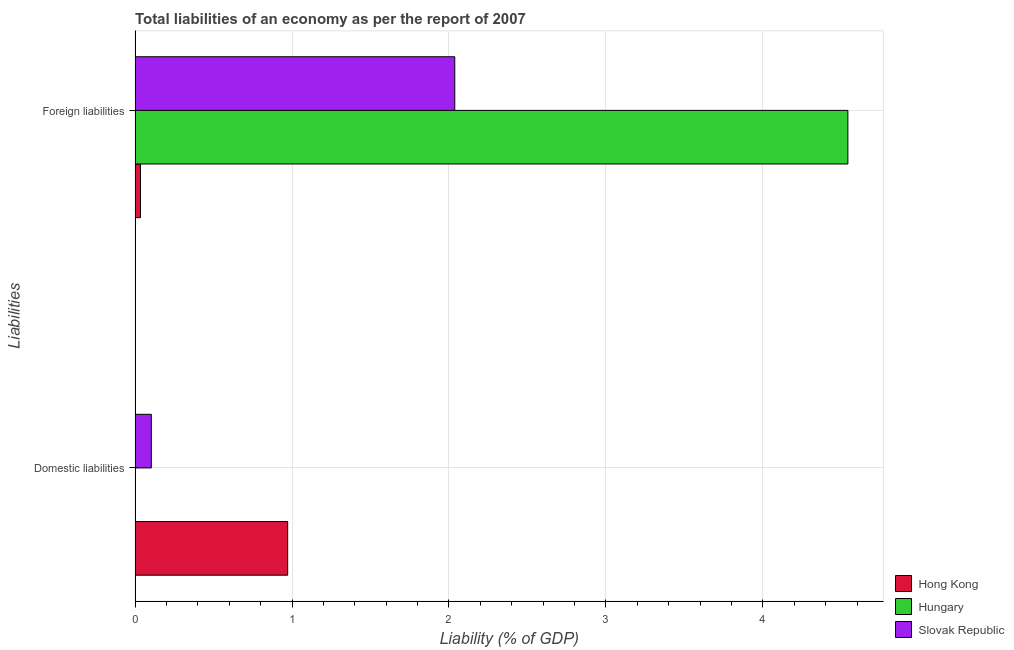Are the number of bars per tick equal to the number of legend labels?
Offer a very short reply. No. Are the number of bars on each tick of the Y-axis equal?
Make the answer very short. No. What is the label of the 1st group of bars from the top?
Offer a terse response. Foreign liabilities. What is the incurrence of foreign liabilities in Hong Kong?
Your response must be concise. 0.03. Across all countries, what is the maximum incurrence of domestic liabilities?
Make the answer very short. 0.97. Across all countries, what is the minimum incurrence of foreign liabilities?
Give a very brief answer. 0.03. In which country was the incurrence of foreign liabilities maximum?
Offer a terse response. Hungary. What is the total incurrence of domestic liabilities in the graph?
Keep it short and to the point. 1.08. What is the difference between the incurrence of foreign liabilities in Hungary and that in Slovak Republic?
Give a very brief answer. 2.5. What is the difference between the incurrence of foreign liabilities in Hong Kong and the incurrence of domestic liabilities in Slovak Republic?
Offer a terse response. -0.07. What is the average incurrence of foreign liabilities per country?
Provide a short and direct response. 2.2. What is the difference between the incurrence of domestic liabilities and incurrence of foreign liabilities in Slovak Republic?
Ensure brevity in your answer.  -1.93. In how many countries, is the incurrence of domestic liabilities greater than 0.2 %?
Ensure brevity in your answer.  1. What is the ratio of the incurrence of foreign liabilities in Slovak Republic to that in Hungary?
Your answer should be very brief. 0.45. In how many countries, is the incurrence of foreign liabilities greater than the average incurrence of foreign liabilities taken over all countries?
Ensure brevity in your answer.  1. How many bars are there?
Ensure brevity in your answer.  5. Are all the bars in the graph horizontal?
Make the answer very short. Yes. What is the difference between two consecutive major ticks on the X-axis?
Make the answer very short. 1. Are the values on the major ticks of X-axis written in scientific E-notation?
Offer a very short reply. No. Does the graph contain any zero values?
Your answer should be very brief. Yes. Does the graph contain grids?
Your answer should be very brief. Yes. Where does the legend appear in the graph?
Ensure brevity in your answer.  Bottom right. How are the legend labels stacked?
Your response must be concise. Vertical. What is the title of the graph?
Offer a very short reply. Total liabilities of an economy as per the report of 2007. Does "North America" appear as one of the legend labels in the graph?
Provide a succinct answer. No. What is the label or title of the X-axis?
Your answer should be compact. Liability (% of GDP). What is the label or title of the Y-axis?
Provide a succinct answer. Liabilities. What is the Liability (% of GDP) in Hong Kong in Domestic liabilities?
Your answer should be compact. 0.97. What is the Liability (% of GDP) in Hungary in Domestic liabilities?
Your answer should be very brief. 0. What is the Liability (% of GDP) in Slovak Republic in Domestic liabilities?
Ensure brevity in your answer.  0.1. What is the Liability (% of GDP) in Hong Kong in Foreign liabilities?
Make the answer very short. 0.03. What is the Liability (% of GDP) of Hungary in Foreign liabilities?
Give a very brief answer. 4.54. What is the Liability (% of GDP) of Slovak Republic in Foreign liabilities?
Provide a short and direct response. 2.04. Across all Liabilities, what is the maximum Liability (% of GDP) of Hong Kong?
Give a very brief answer. 0.97. Across all Liabilities, what is the maximum Liability (% of GDP) of Hungary?
Your answer should be very brief. 4.54. Across all Liabilities, what is the maximum Liability (% of GDP) in Slovak Republic?
Provide a succinct answer. 2.04. Across all Liabilities, what is the minimum Liability (% of GDP) of Hong Kong?
Your response must be concise. 0.03. Across all Liabilities, what is the minimum Liability (% of GDP) of Hungary?
Your answer should be very brief. 0. Across all Liabilities, what is the minimum Liability (% of GDP) in Slovak Republic?
Keep it short and to the point. 0.1. What is the total Liability (% of GDP) of Hong Kong in the graph?
Give a very brief answer. 1.01. What is the total Liability (% of GDP) in Hungary in the graph?
Provide a succinct answer. 4.54. What is the total Liability (% of GDP) in Slovak Republic in the graph?
Give a very brief answer. 2.14. What is the difference between the Liability (% of GDP) in Hong Kong in Domestic liabilities and that in Foreign liabilities?
Offer a terse response. 0.94. What is the difference between the Liability (% of GDP) of Slovak Republic in Domestic liabilities and that in Foreign liabilities?
Provide a short and direct response. -1.93. What is the difference between the Liability (% of GDP) in Hong Kong in Domestic liabilities and the Liability (% of GDP) in Hungary in Foreign liabilities?
Give a very brief answer. -3.57. What is the difference between the Liability (% of GDP) in Hong Kong in Domestic liabilities and the Liability (% of GDP) in Slovak Republic in Foreign liabilities?
Ensure brevity in your answer.  -1.06. What is the average Liability (% of GDP) of Hong Kong per Liabilities?
Make the answer very short. 0.5. What is the average Liability (% of GDP) of Hungary per Liabilities?
Provide a short and direct response. 2.27. What is the average Liability (% of GDP) in Slovak Republic per Liabilities?
Provide a succinct answer. 1.07. What is the difference between the Liability (% of GDP) in Hong Kong and Liability (% of GDP) in Slovak Republic in Domestic liabilities?
Ensure brevity in your answer.  0.87. What is the difference between the Liability (% of GDP) of Hong Kong and Liability (% of GDP) of Hungary in Foreign liabilities?
Make the answer very short. -4.51. What is the difference between the Liability (% of GDP) of Hong Kong and Liability (% of GDP) of Slovak Republic in Foreign liabilities?
Your answer should be very brief. -2. What is the difference between the Liability (% of GDP) of Hungary and Liability (% of GDP) of Slovak Republic in Foreign liabilities?
Offer a very short reply. 2.5. What is the ratio of the Liability (% of GDP) in Hong Kong in Domestic liabilities to that in Foreign liabilities?
Keep it short and to the point. 28.16. What is the ratio of the Liability (% of GDP) in Slovak Republic in Domestic liabilities to that in Foreign liabilities?
Make the answer very short. 0.05. What is the difference between the highest and the second highest Liability (% of GDP) in Hong Kong?
Offer a very short reply. 0.94. What is the difference between the highest and the second highest Liability (% of GDP) of Slovak Republic?
Offer a very short reply. 1.93. What is the difference between the highest and the lowest Liability (% of GDP) of Hong Kong?
Provide a succinct answer. 0.94. What is the difference between the highest and the lowest Liability (% of GDP) in Hungary?
Provide a short and direct response. 4.54. What is the difference between the highest and the lowest Liability (% of GDP) in Slovak Republic?
Offer a very short reply. 1.93. 